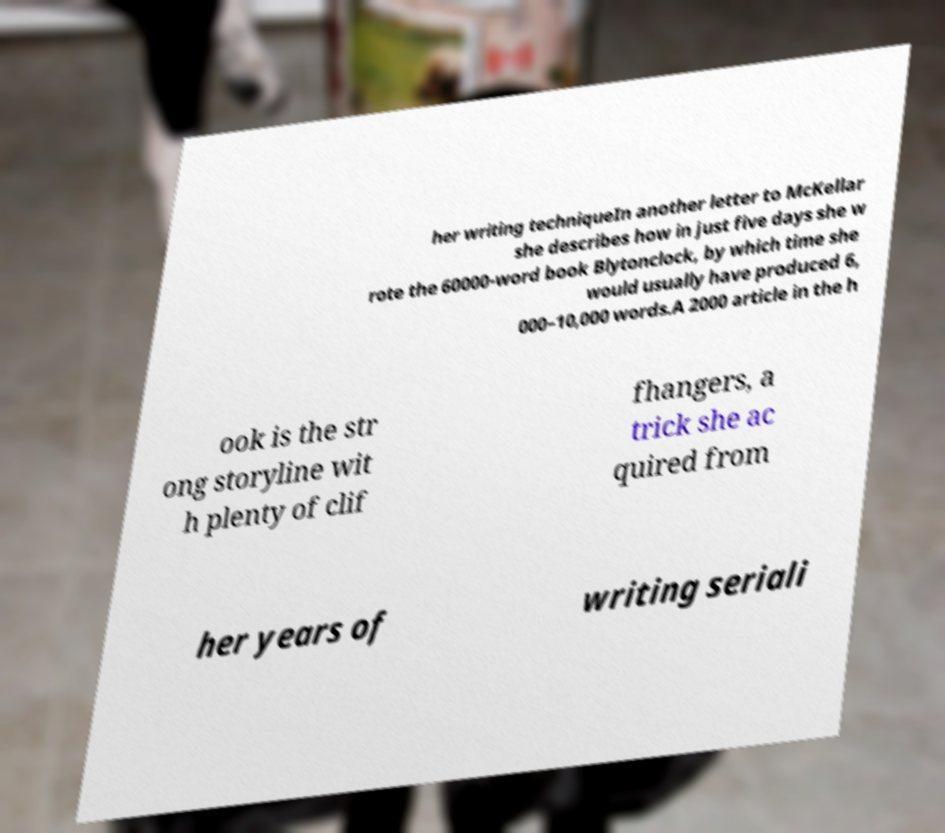For documentation purposes, I need the text within this image transcribed. Could you provide that? her writing techniqueIn another letter to McKellar she describes how in just five days she w rote the 60000-word book Blytonclock, by which time she would usually have produced 6, 000–10,000 words.A 2000 article in the h ook is the str ong storyline wit h plenty of clif fhangers, a trick she ac quired from her years of writing seriali 